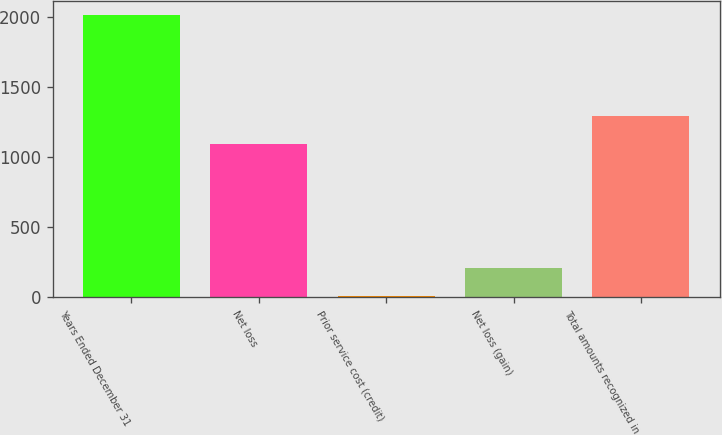Convert chart. <chart><loc_0><loc_0><loc_500><loc_500><bar_chart><fcel>Years Ended December 31<fcel>Net loss<fcel>Prior service cost (credit)<fcel>Net loss (gain)<fcel>Total amounts recognized in<nl><fcel>2012<fcel>1095<fcel>13<fcel>212.9<fcel>1294.9<nl></chart> 